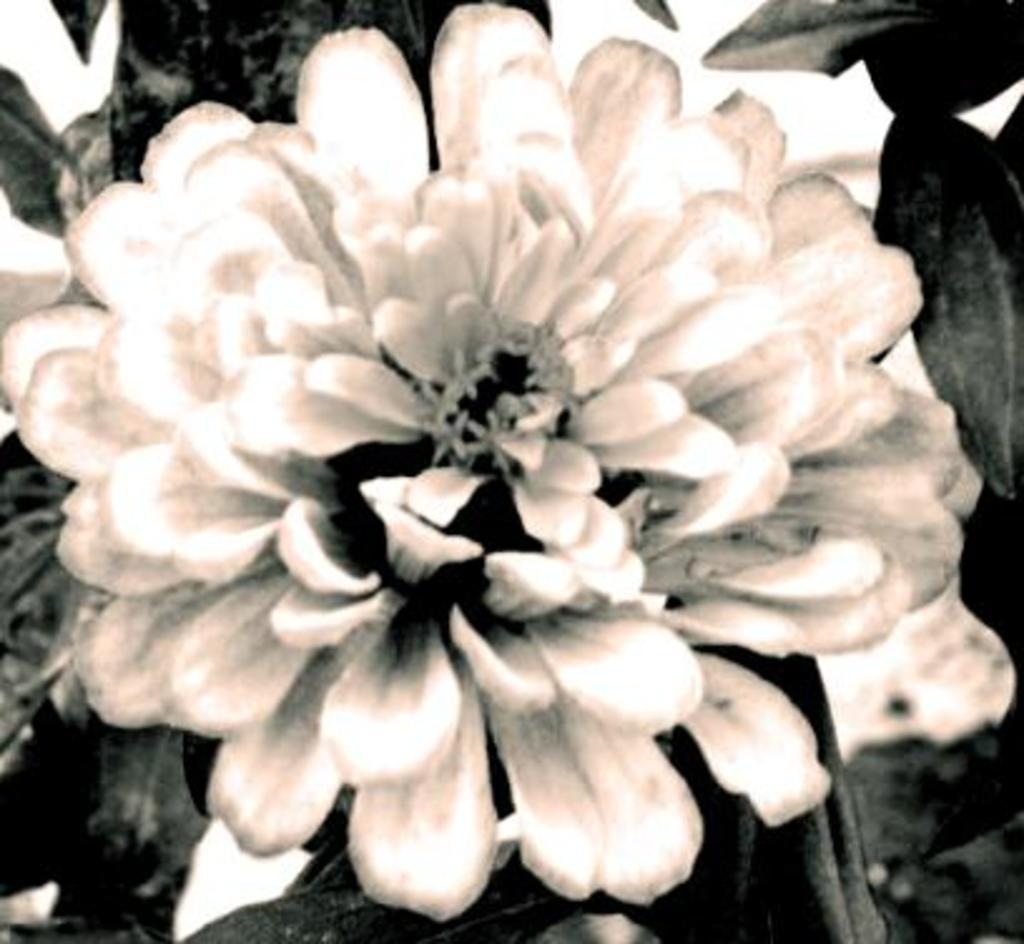What is the main subject of the image? There is a flower in the image. What is the color scheme of the image? The image is black and white. How many giants are holding the flower in the image? There are no giants present in the image, and therefore no such activity can be observed. What type of wine is being served with the flower in the image? There is no wine present in the image, as it only features a flower. 